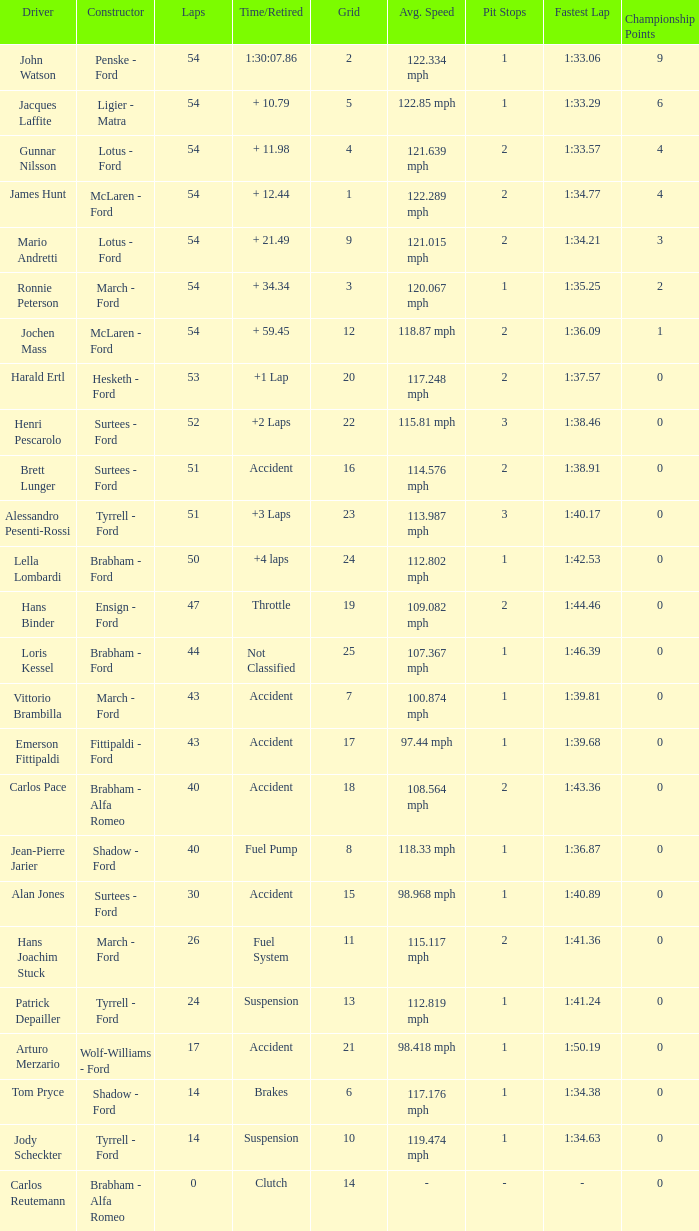What is the Time/Retired of Carlos Reutemann who was driving a brabham - Alfa Romeo? Clutch. 